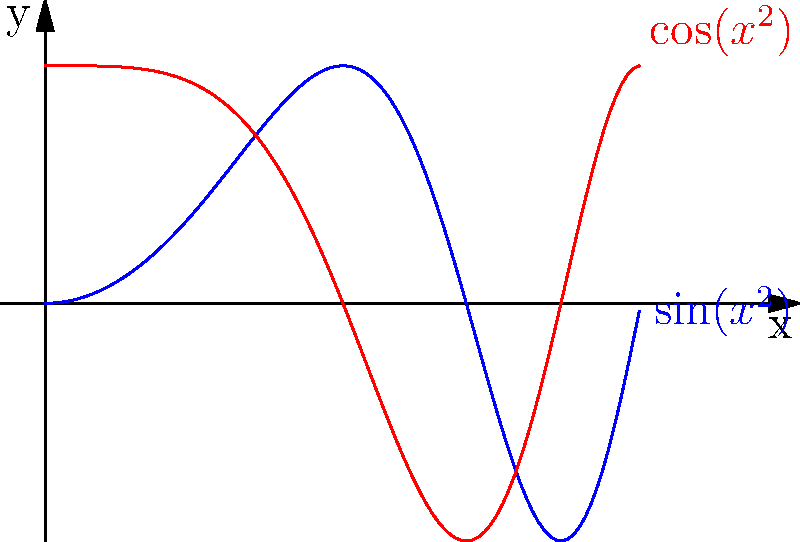In your novel, you're describing a character's unpredictable journey through life, which reminds you of a double pendulum's chaotic behavior. The graph shows two functions, $\sin(x^2)$ and $\cos(x^2)$, representing the angular positions of the two pendulum arms over time. How would you characterize the relationship between these functions, and what might this reveal about the nature of chance in your character's life? To understand the relationship between $\sin(x^2)$ and $\cos(x^2)$ and their relevance to a character's journey:

1. Observe the functions:
   - Blue curve: $\sin(x^2)$
   - Red curve: $\cos(x^2)$

2. Note the key characteristics:
   a) Both functions oscillate but with increasing frequency as x increases.
   b) They are out of phase with each other, similar to the two arms of a double pendulum.

3. Analyze the behavior:
   - For small x, the oscillations are slow and predictable.
   - As x increases, the oscillations become rapid and less predictable.

4. Relate to chaotic systems:
   - This behavior is analogous to a double pendulum, where small changes in initial conditions lead to vastly different outcomes over time.

5. Connect to character development:
   - The initial, slower oscillations represent more predictable early life events.
   - The later, rapid oscillations symbolize how small choices or chance events can lead to dramatically different life paths.

6. Interpret the interplay of the functions:
   - The out-of-phase nature shows how different aspects of life (represented by each pendulum arm) can influence each other in complex ways.

7. Consider the implications for storytelling:
   - This model suggests that while early events might be somewhat predictable, the compounding effects of choices and chance make long-term outcomes inherently uncertain.
Answer: The functions exhibit increasing oscillation frequency and phase difference, symbolizing how small initial variations in a character's life can lead to vastly different outcomes over time, embodying the unpredictable nature of chance in storytelling. 